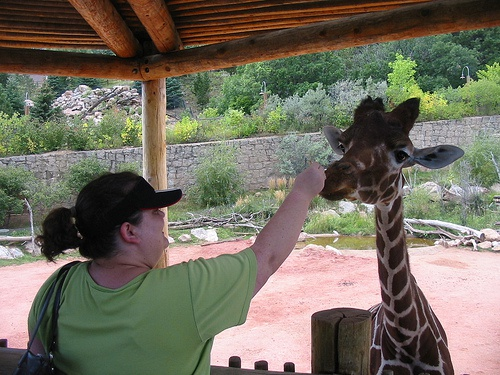Describe the objects in this image and their specific colors. I can see people in black and gray tones, giraffe in black, gray, and darkgray tones, and handbag in black, gray, and darkgreen tones in this image. 